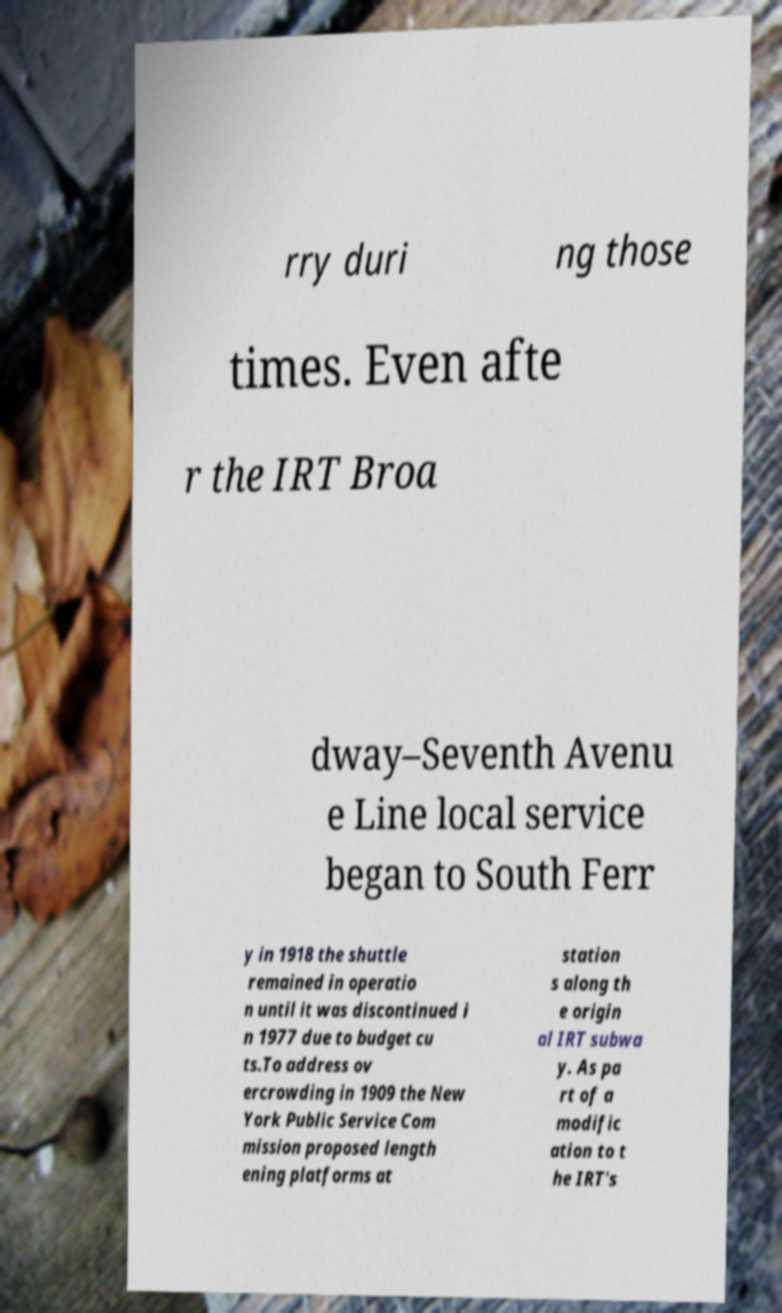Could you extract and type out the text from this image? rry duri ng those times. Even afte r the IRT Broa dway–Seventh Avenu e Line local service began to South Ferr y in 1918 the shuttle remained in operatio n until it was discontinued i n 1977 due to budget cu ts.To address ov ercrowding in 1909 the New York Public Service Com mission proposed length ening platforms at station s along th e origin al IRT subwa y. As pa rt of a modific ation to t he IRT's 